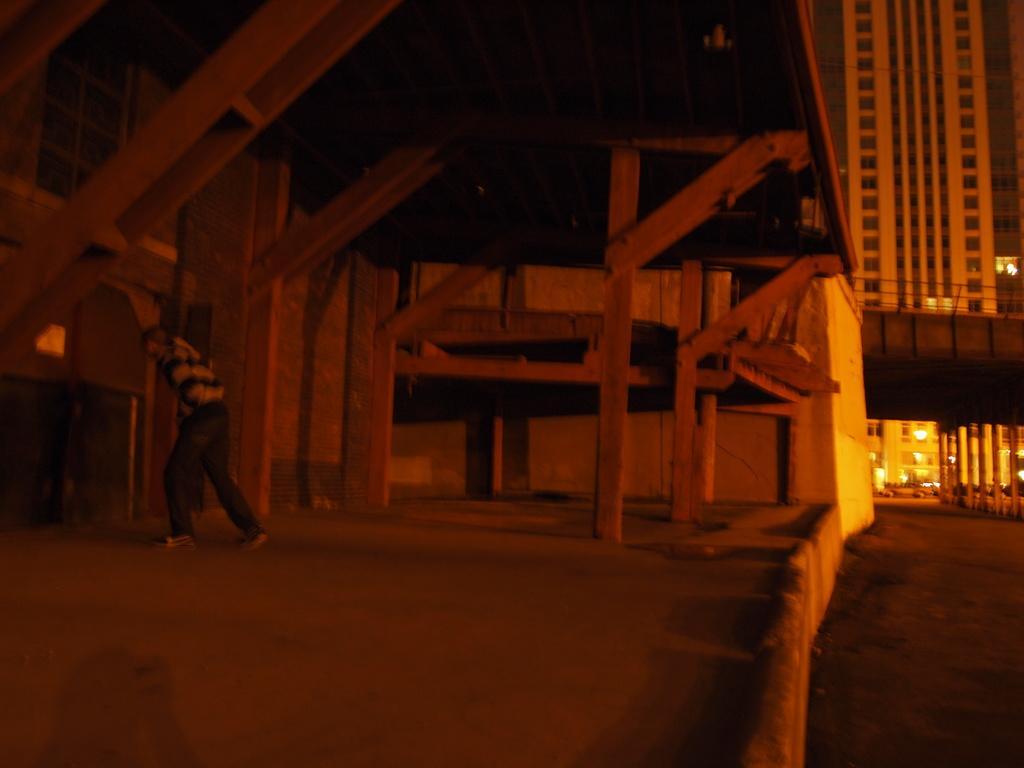Describe this image in one or two sentences. On the right side of the picture there are buildings, bridge, vehicles and road. On the left there are wooden frames and a man standing. 